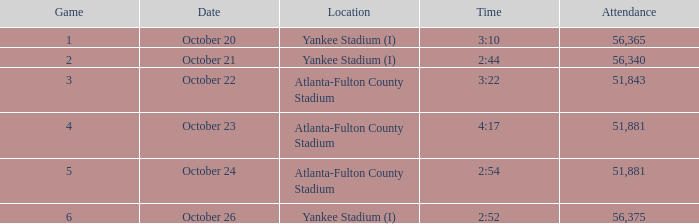What is the top game number with a time of 2:44? 2.0. 